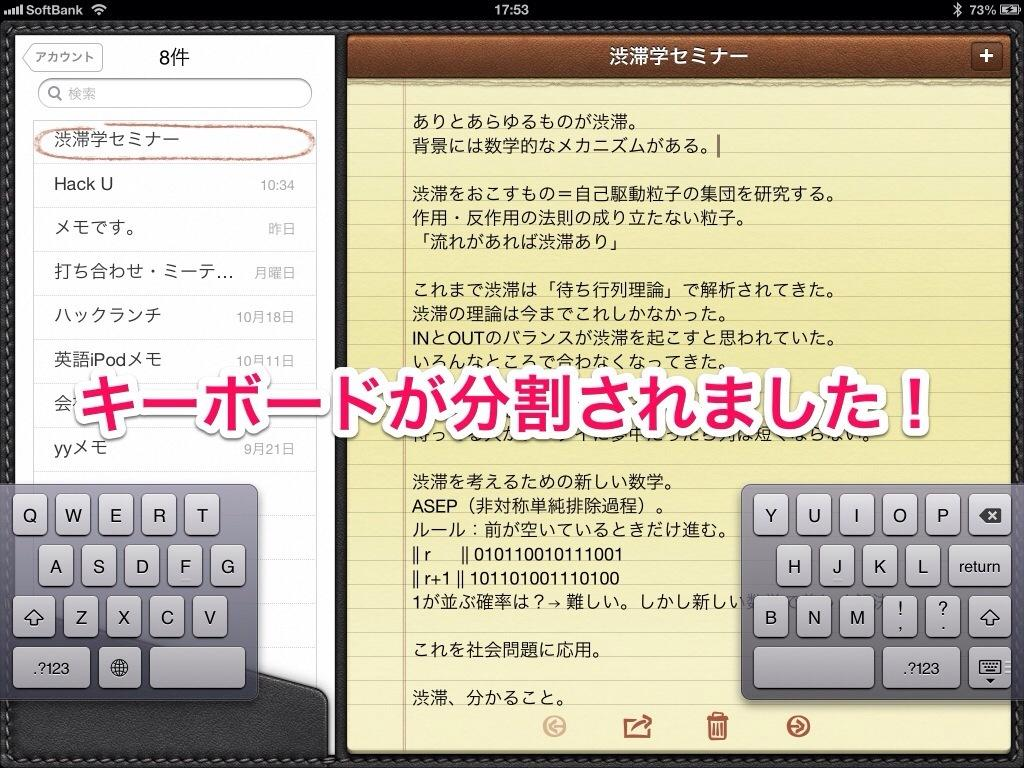<image>
Describe the image concisely. SoftBank is an Asian service available on tablets. 